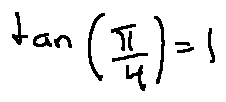<formula> <loc_0><loc_0><loc_500><loc_500>\tan ( \frac { \pi } { 4 } ) = 1</formula> 